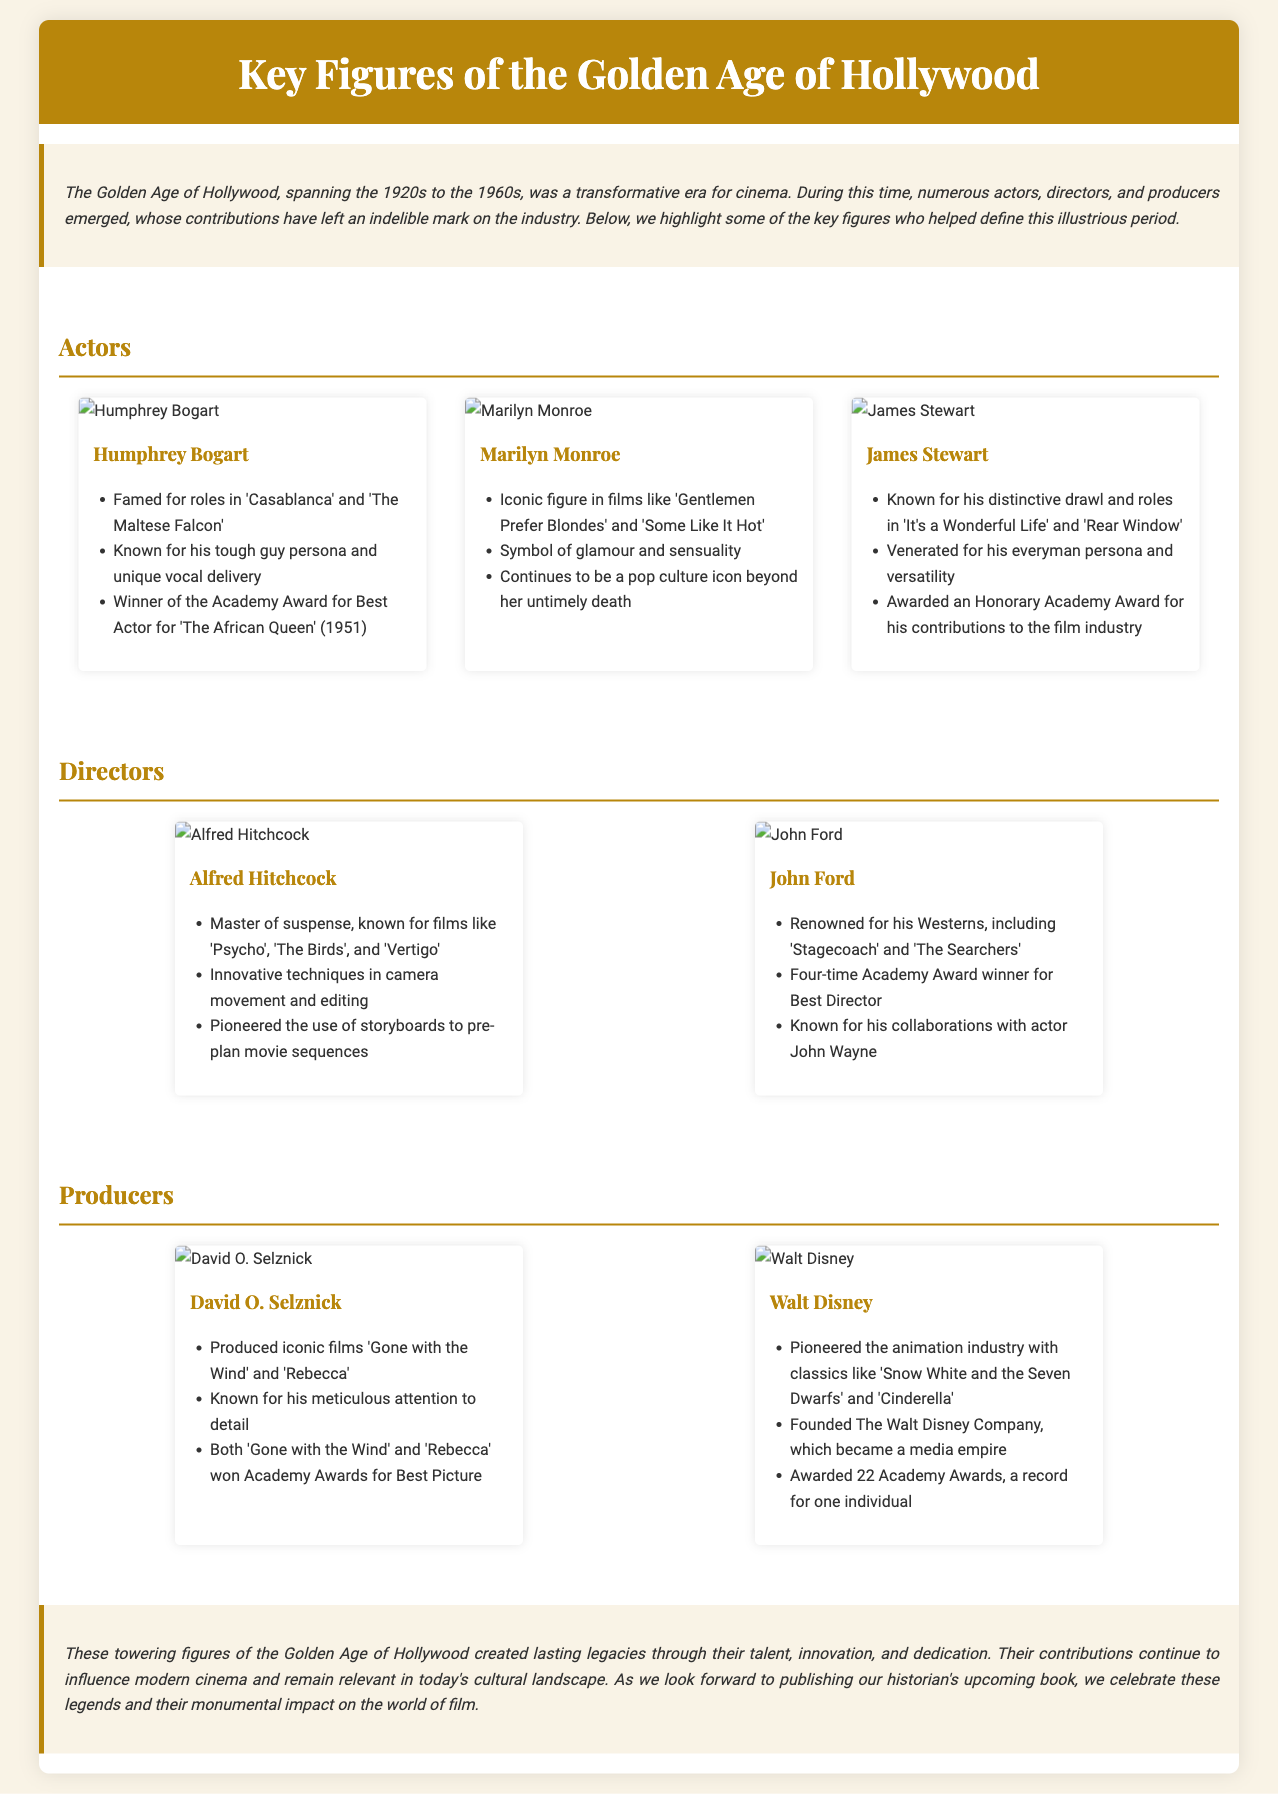What films is Humphrey Bogart famed for? The document lists 'Casablanca' and 'The Maltese Falcon' as notable films for Humphrey Bogart.
Answer: 'Casablanca' and 'The Maltese Falcon' Which actress is a symbol of glamour and sensuality? The profile of Marilyn Monroe highlights her as a key figure symbolizing glamour and sensuality.
Answer: Marilyn Monroe How many Academy Awards did John Ford win for Best Director? The document states that John Ford is a four-time Academy Award winner for Best Director.
Answer: Four What innovative techniques did Alfred Hitchcock pioneer? According to the document, Alfred Hitchcock was known for innovative techniques in camera movement and editing.
Answer: Camera movement and editing What animated classic did Walt Disney pioneer? The document mentions 'Snow White and the Seven Dwarfs' as one of the classics pioneered by Walt Disney.
Answer: 'Snow White and the Seven Dwarfs' Who produced 'Gone with the Wind'? The document indicates that David O. Selznick produced 'Gone with the Wind'.
Answer: David O. Selznick In which year was Humphrey Bogart awarded the Academy Award for Best Actor? The document notes that Humphrey Bogart won this award for his role in 'The African Queen' in 1951.
Answer: 1951 What is a common theme among the key figures highlighted in this document? The profiles emphasize the legacies and lasting impacts these figures had on the film industry.
Answer: Legacies and lasting impacts 